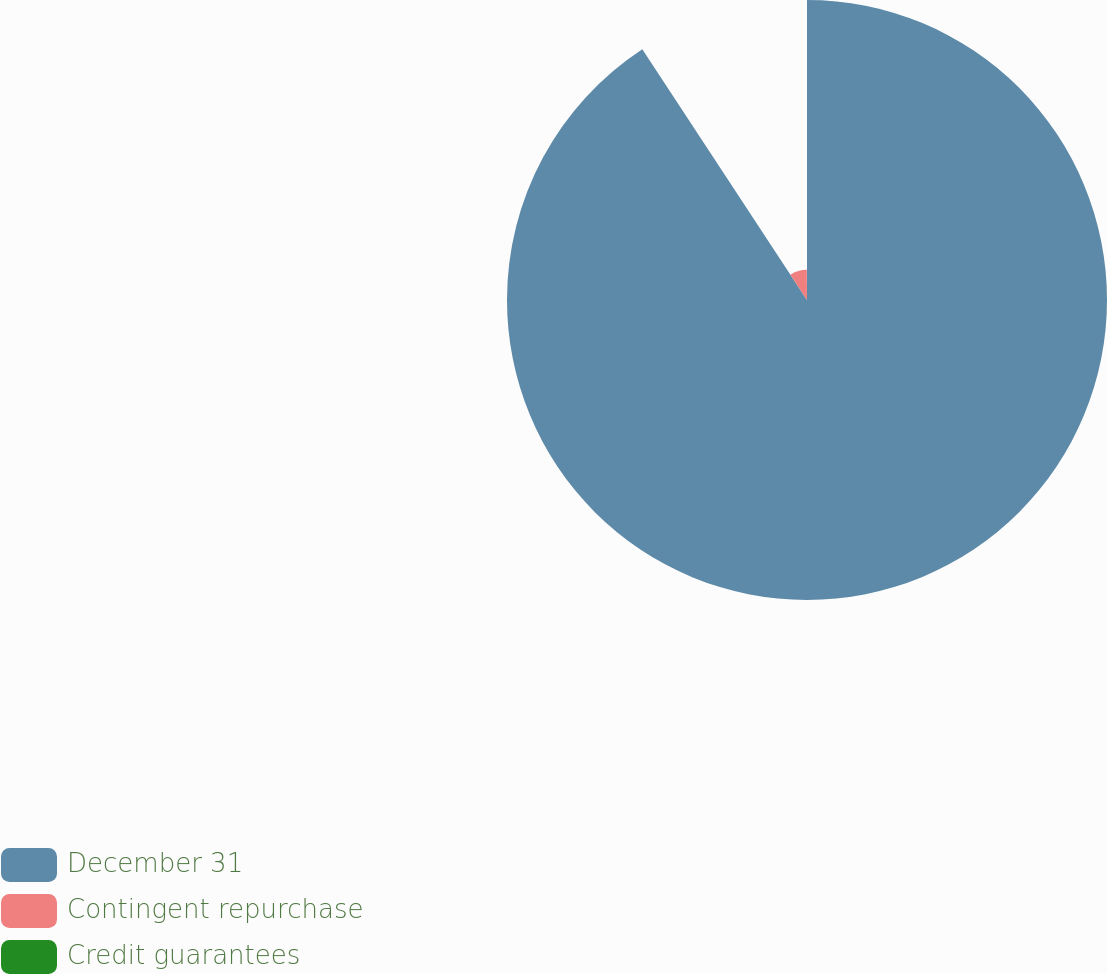Convert chart. <chart><loc_0><loc_0><loc_500><loc_500><pie_chart><fcel>December 31<fcel>Contingent repurchase<fcel>Credit guarantees<nl><fcel>90.75%<fcel>9.16%<fcel>0.09%<nl></chart> 